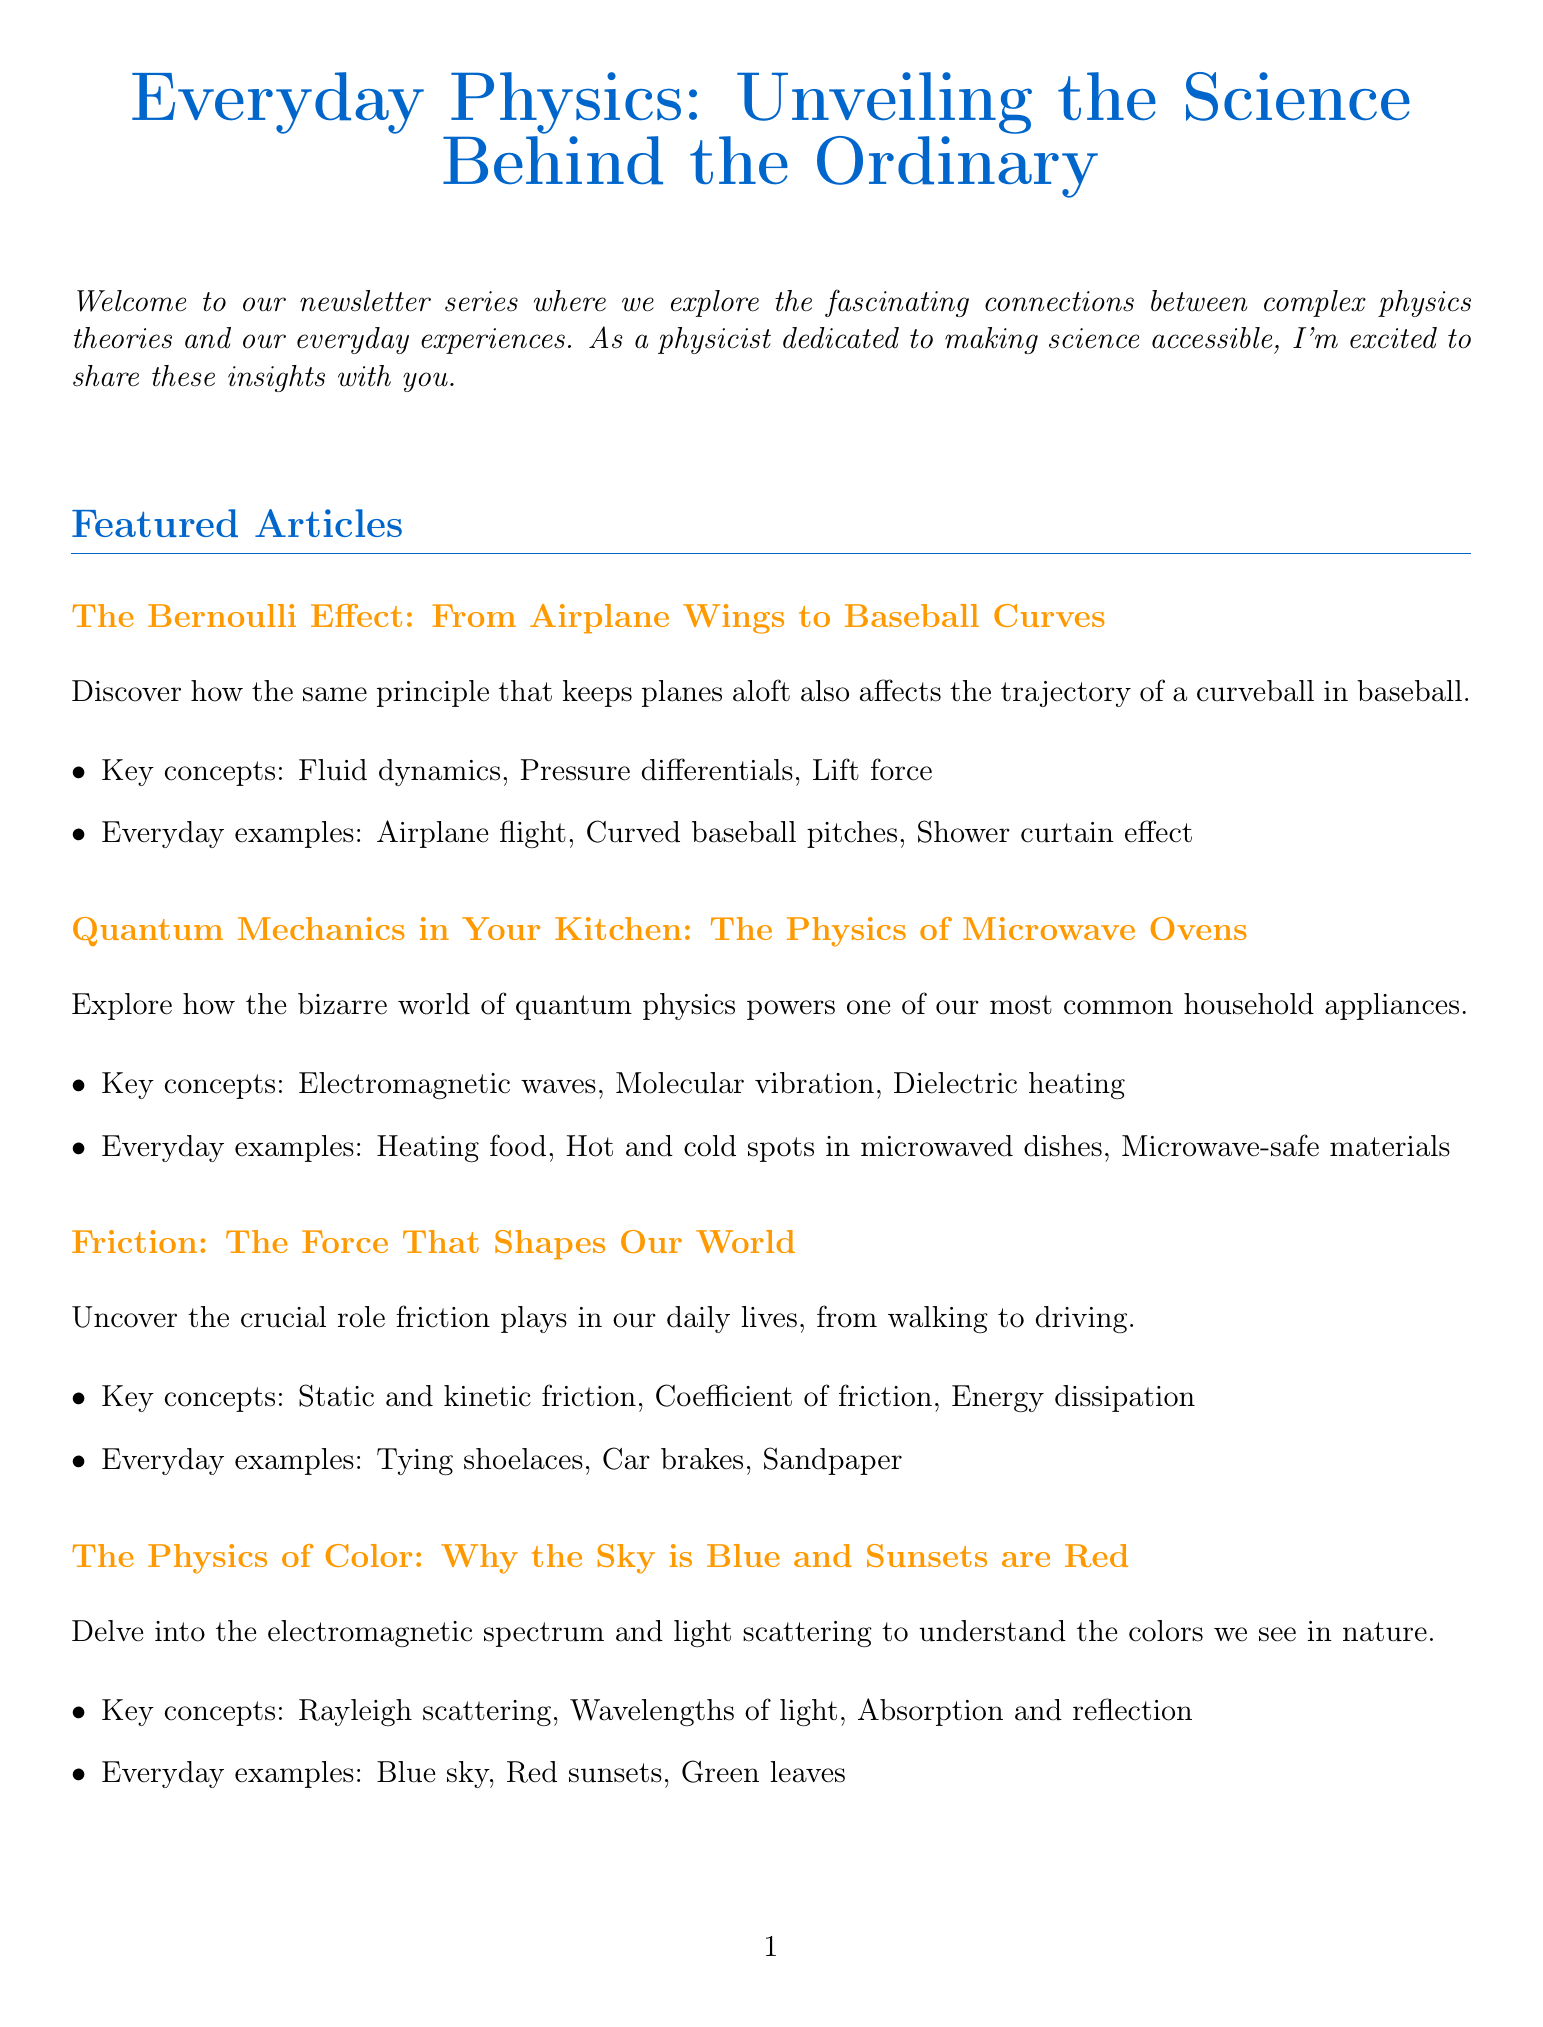What is the title of the newsletter? The title of the newsletter is provided at the beginning of the document.
Answer: Everyday Physics: Unveiling the Science Behind the Ordinary Who is the author of the newsletter? The author's name is mentioned in the section about the author.
Answer: Dr. Samantha Lee What is the main focus of the article titled "The Physics of Color"? The article provides insights on a specific phenomenon related to light.
Answer: Light scattering What is one everyday example related to the Bernoulli Effect? Everyday examples are listed in the article summary about the Bernoulli Effect.
Answer: Curved baseball pitches What is the question of the month? The question of the month is explicitly stated in the reader engagement section.
Answer: How does a bicycle stay upright when in motion? What is one recommended experiment at home? The home experiment suggestion is found in the reader engagement section.
Answer: Observe the Coriolis effect using a rotating turntable and a rolling ball What is one key concept discussed in the article about microwave ovens? Key concepts are summarized in the article section for microwave ovens.
Answer: Electromagnetic waves What topic will be discussed in the upcoming series focusing on music? Upcoming topics are provided in a list format under upcoming topics.
Answer: The physics of music and sound 